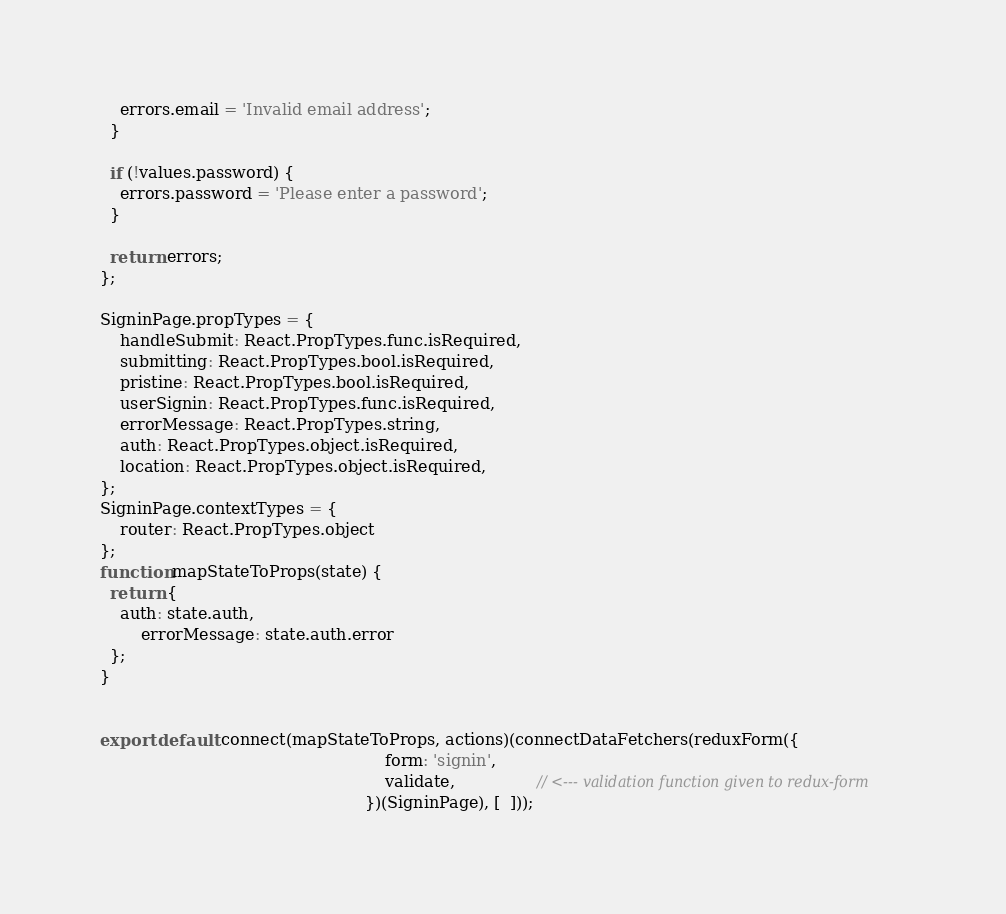<code> <loc_0><loc_0><loc_500><loc_500><_JavaScript_>    errors.email = 'Invalid email address';
  }

  if (!values.password) {
    errors.password = 'Please enter a password';
  }

  return errors;
};

SigninPage.propTypes = {
	handleSubmit: React.PropTypes.func.isRequired,
	submitting: React.PropTypes.bool.isRequired,
	pristine: React.PropTypes.bool.isRequired,
	userSignin: React.PropTypes.func.isRequired,
	errorMessage: React.PropTypes.string,
	auth: React.PropTypes.object.isRequired,
	location: React.PropTypes.object.isRequired,
};
SigninPage.contextTypes = {
	router: React.PropTypes.object
};
function mapStateToProps(state) {
  return {
    auth: state.auth,
		errorMessage: state.auth.error
  };
}


export default connect(mapStateToProps, actions)(connectDataFetchers(reduxForm({
														form: 'signin',
														validate,                // <--- validation function given to redux-form
													})(SigninPage), [  ]));
</code> 